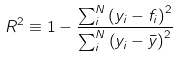<formula> <loc_0><loc_0><loc_500><loc_500>R ^ { 2 } \equiv 1 - \frac { \sum _ { i } ^ { N } \left ( y _ { i } - f _ { i } \right ) ^ { 2 } } { \sum _ { i } ^ { N } \left ( y _ { i } - \bar { y } \right ) ^ { 2 } }</formula> 